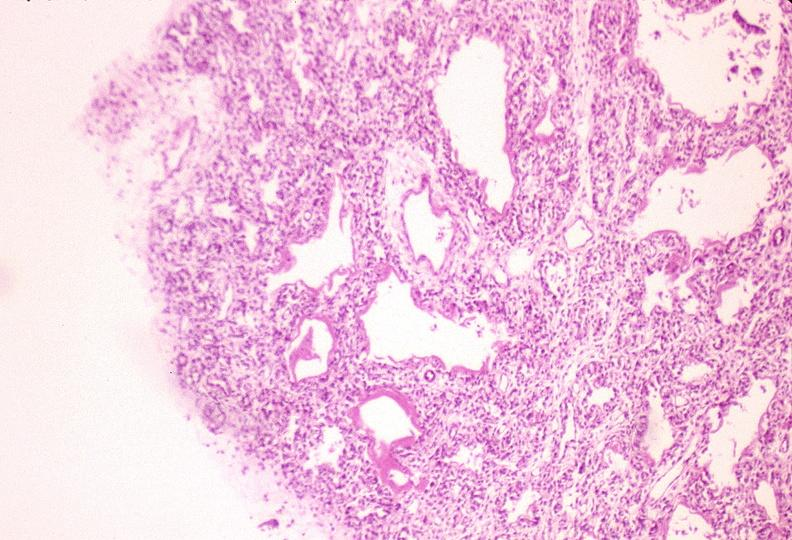what does this image show?
Answer the question using a single word or phrase. Lungs 